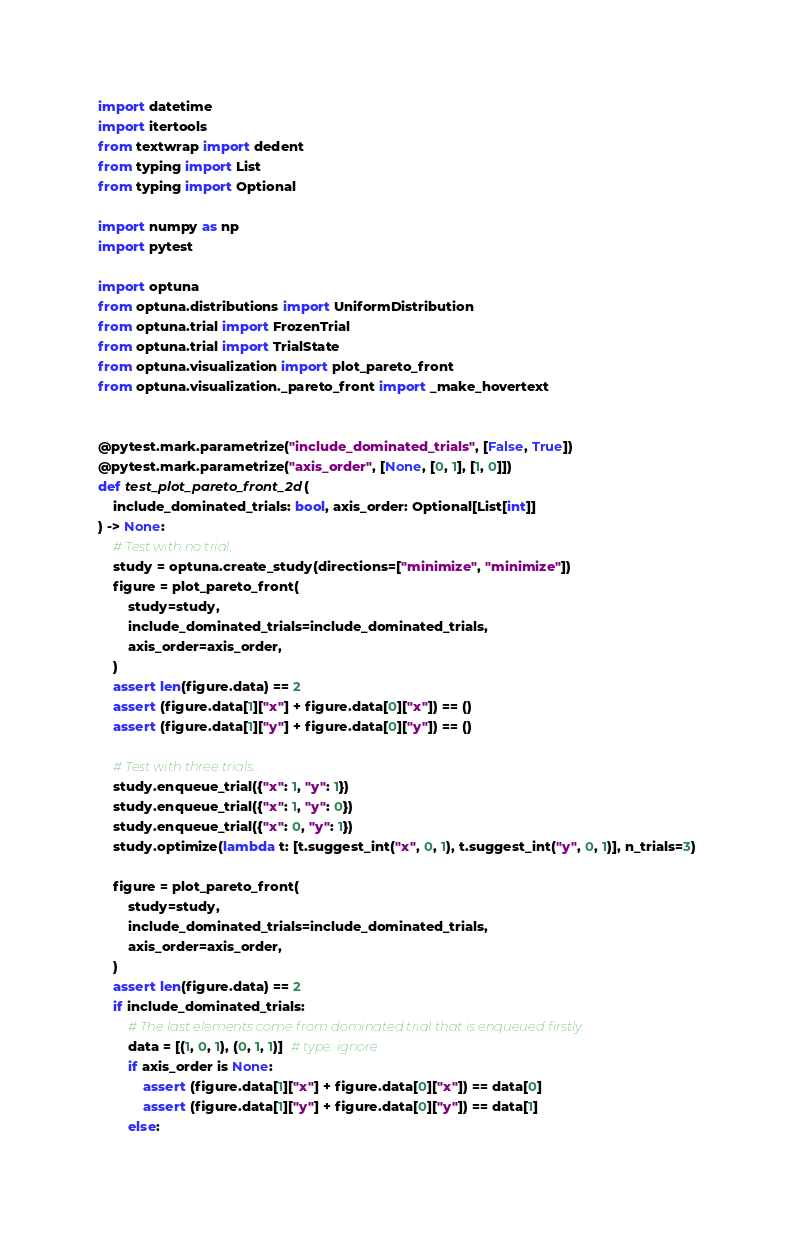Convert code to text. <code><loc_0><loc_0><loc_500><loc_500><_Python_>import datetime
import itertools
from textwrap import dedent
from typing import List
from typing import Optional

import numpy as np
import pytest

import optuna
from optuna.distributions import UniformDistribution
from optuna.trial import FrozenTrial
from optuna.trial import TrialState
from optuna.visualization import plot_pareto_front
from optuna.visualization._pareto_front import _make_hovertext


@pytest.mark.parametrize("include_dominated_trials", [False, True])
@pytest.mark.parametrize("axis_order", [None, [0, 1], [1, 0]])
def test_plot_pareto_front_2d(
    include_dominated_trials: bool, axis_order: Optional[List[int]]
) -> None:
    # Test with no trial.
    study = optuna.create_study(directions=["minimize", "minimize"])
    figure = plot_pareto_front(
        study=study,
        include_dominated_trials=include_dominated_trials,
        axis_order=axis_order,
    )
    assert len(figure.data) == 2
    assert (figure.data[1]["x"] + figure.data[0]["x"]) == ()
    assert (figure.data[1]["y"] + figure.data[0]["y"]) == ()

    # Test with three trials.
    study.enqueue_trial({"x": 1, "y": 1})
    study.enqueue_trial({"x": 1, "y": 0})
    study.enqueue_trial({"x": 0, "y": 1})
    study.optimize(lambda t: [t.suggest_int("x", 0, 1), t.suggest_int("y", 0, 1)], n_trials=3)

    figure = plot_pareto_front(
        study=study,
        include_dominated_trials=include_dominated_trials,
        axis_order=axis_order,
    )
    assert len(figure.data) == 2
    if include_dominated_trials:
        # The last elements come from dominated trial that is enqueued firstly.
        data = [(1, 0, 1), (0, 1, 1)]  # type: ignore
        if axis_order is None:
            assert (figure.data[1]["x"] + figure.data[0]["x"]) == data[0]
            assert (figure.data[1]["y"] + figure.data[0]["y"]) == data[1]
        else:</code> 